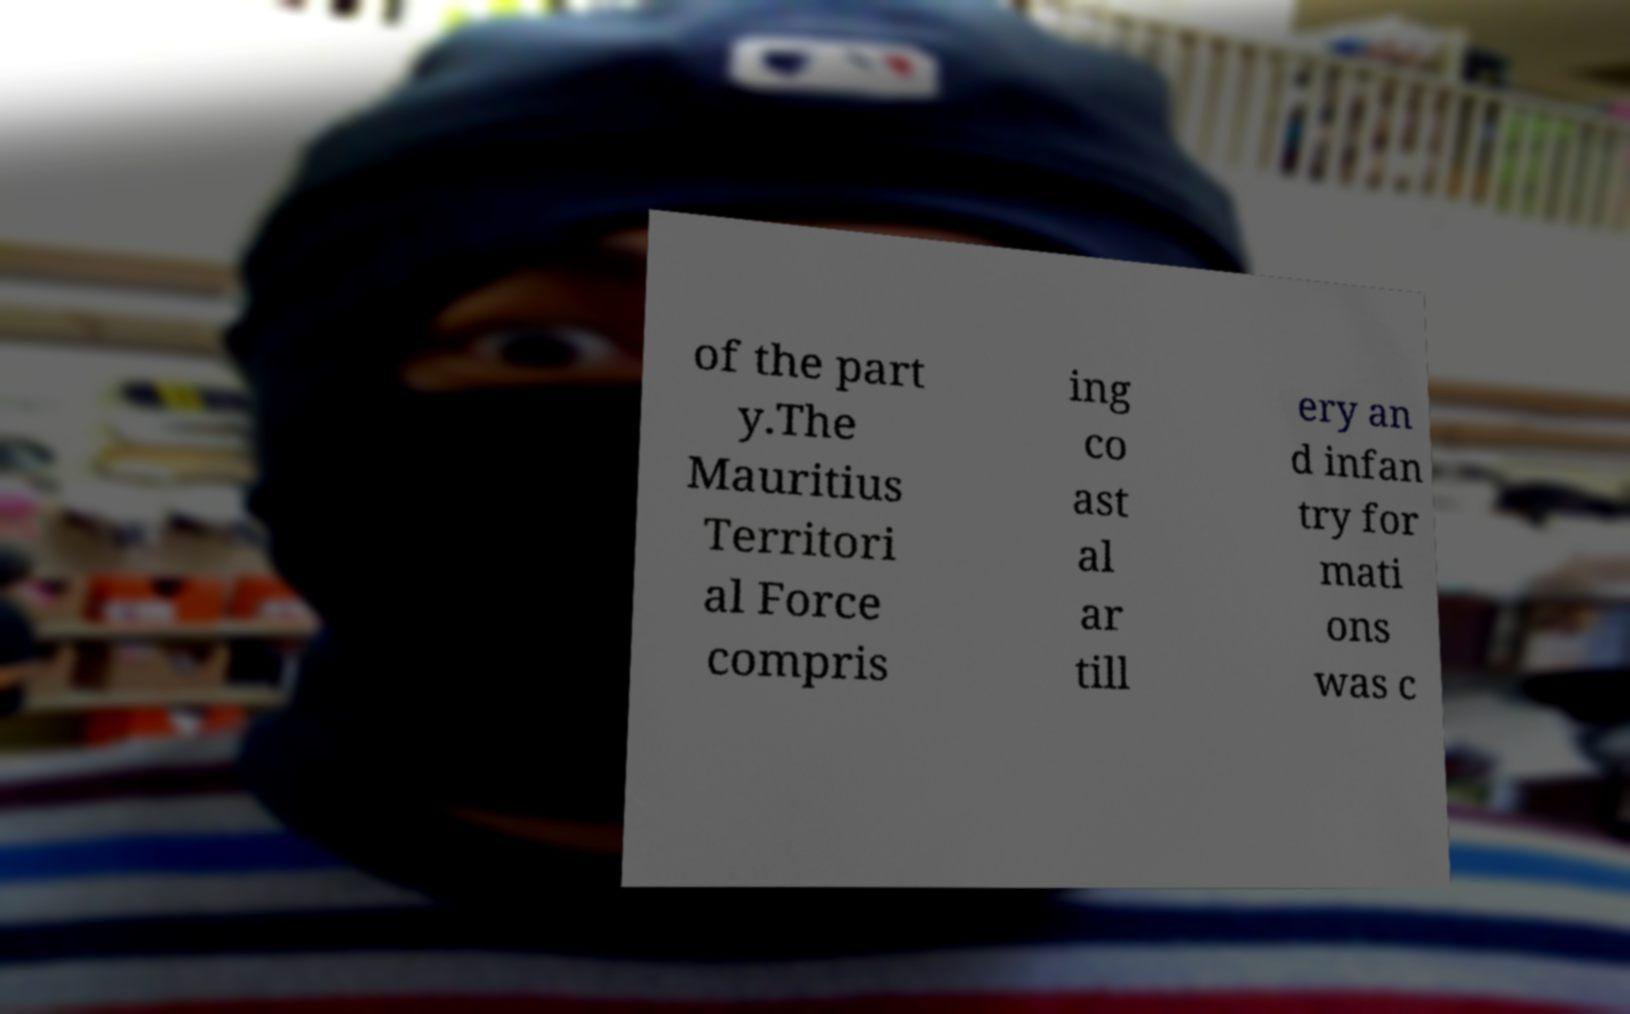For documentation purposes, I need the text within this image transcribed. Could you provide that? of the part y.The Mauritius Territori al Force compris ing co ast al ar till ery an d infan try for mati ons was c 